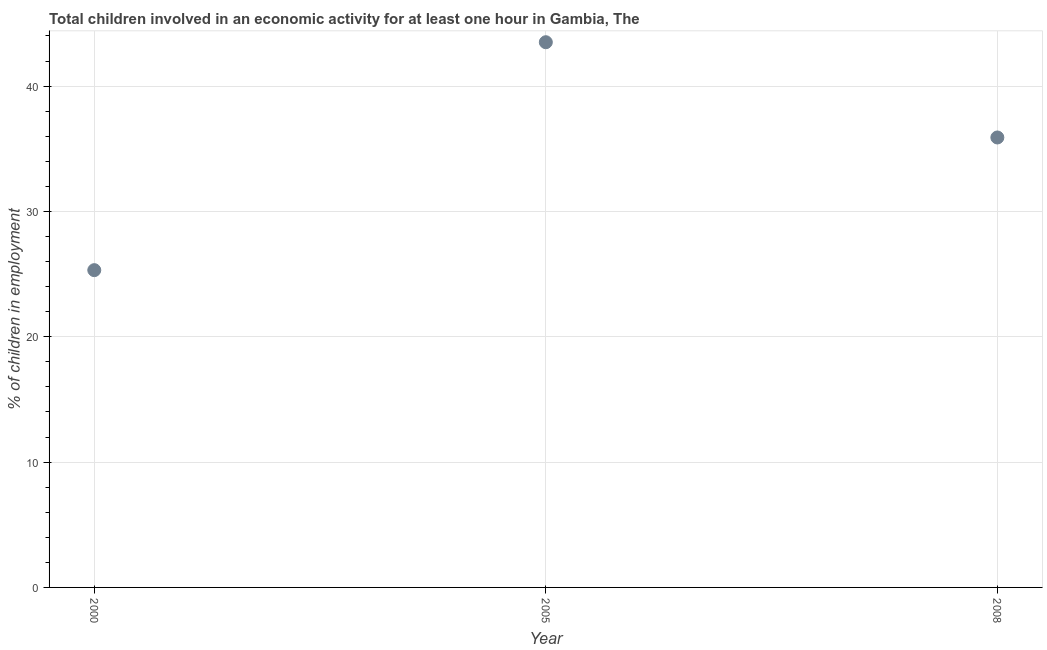What is the percentage of children in employment in 2000?
Your answer should be compact. 25.31. Across all years, what is the maximum percentage of children in employment?
Your answer should be very brief. 43.5. Across all years, what is the minimum percentage of children in employment?
Keep it short and to the point. 25.31. In which year was the percentage of children in employment minimum?
Your answer should be compact. 2000. What is the sum of the percentage of children in employment?
Your response must be concise. 104.71. What is the difference between the percentage of children in employment in 2005 and 2008?
Provide a short and direct response. 7.6. What is the average percentage of children in employment per year?
Provide a succinct answer. 34.9. What is the median percentage of children in employment?
Make the answer very short. 35.9. In how many years, is the percentage of children in employment greater than 2 %?
Give a very brief answer. 3. Do a majority of the years between 2000 and 2005 (inclusive) have percentage of children in employment greater than 36 %?
Your response must be concise. No. What is the ratio of the percentage of children in employment in 2005 to that in 2008?
Your answer should be compact. 1.21. Is the difference between the percentage of children in employment in 2000 and 2008 greater than the difference between any two years?
Offer a terse response. No. What is the difference between the highest and the second highest percentage of children in employment?
Your response must be concise. 7.6. Is the sum of the percentage of children in employment in 2005 and 2008 greater than the maximum percentage of children in employment across all years?
Offer a terse response. Yes. What is the difference between the highest and the lowest percentage of children in employment?
Provide a short and direct response. 18.19. In how many years, is the percentage of children in employment greater than the average percentage of children in employment taken over all years?
Ensure brevity in your answer.  2. What is the difference between two consecutive major ticks on the Y-axis?
Your answer should be compact. 10. Are the values on the major ticks of Y-axis written in scientific E-notation?
Give a very brief answer. No. What is the title of the graph?
Your answer should be very brief. Total children involved in an economic activity for at least one hour in Gambia, The. What is the label or title of the X-axis?
Ensure brevity in your answer.  Year. What is the label or title of the Y-axis?
Your answer should be very brief. % of children in employment. What is the % of children in employment in 2000?
Your response must be concise. 25.31. What is the % of children in employment in 2005?
Your answer should be compact. 43.5. What is the % of children in employment in 2008?
Your response must be concise. 35.9. What is the difference between the % of children in employment in 2000 and 2005?
Provide a succinct answer. -18.19. What is the difference between the % of children in employment in 2000 and 2008?
Ensure brevity in your answer.  -10.59. What is the difference between the % of children in employment in 2005 and 2008?
Your response must be concise. 7.6. What is the ratio of the % of children in employment in 2000 to that in 2005?
Offer a very short reply. 0.58. What is the ratio of the % of children in employment in 2000 to that in 2008?
Offer a terse response. 0.7. What is the ratio of the % of children in employment in 2005 to that in 2008?
Ensure brevity in your answer.  1.21. 